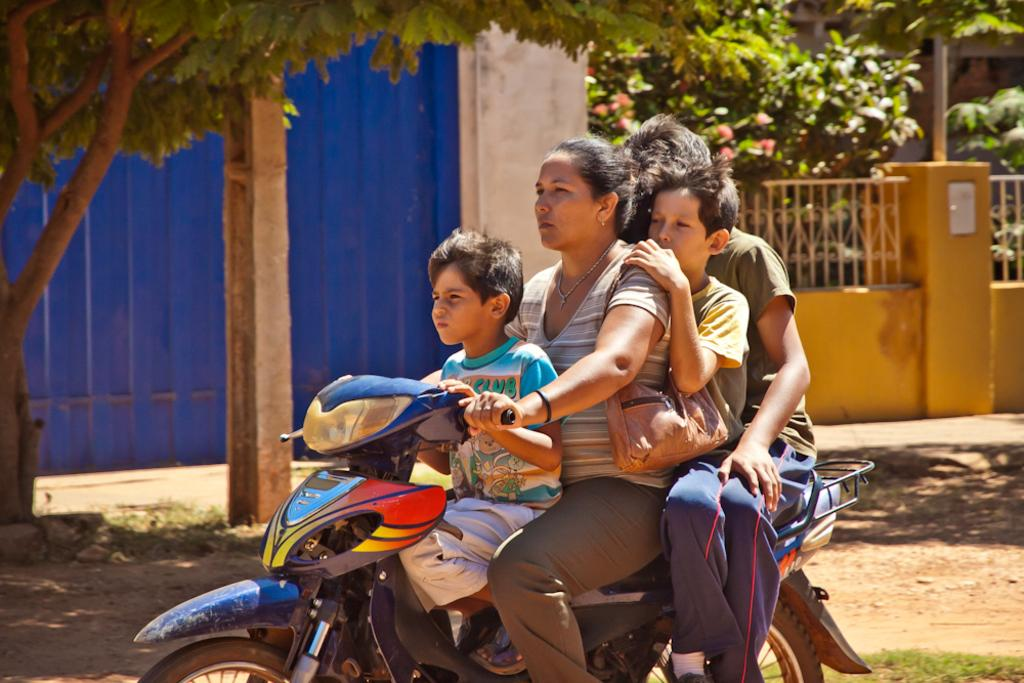What is the woman doing in the image? The woman is driving a motorcycle in the image. Who is with the woman on the motorcycle? A boy is sitting in front of the woman on the motorcycle. How many people are sitting on the motorcycle in total? There are two people sitting in the back of the motorcycle, in addition to the woman and the boy, making a total of four people on the motorcycle. What type of honey is being harvested by the woman in the image? There is no honey or honey harvesting activity present in the image; it features a woman driving a motorcycle with passengers. 